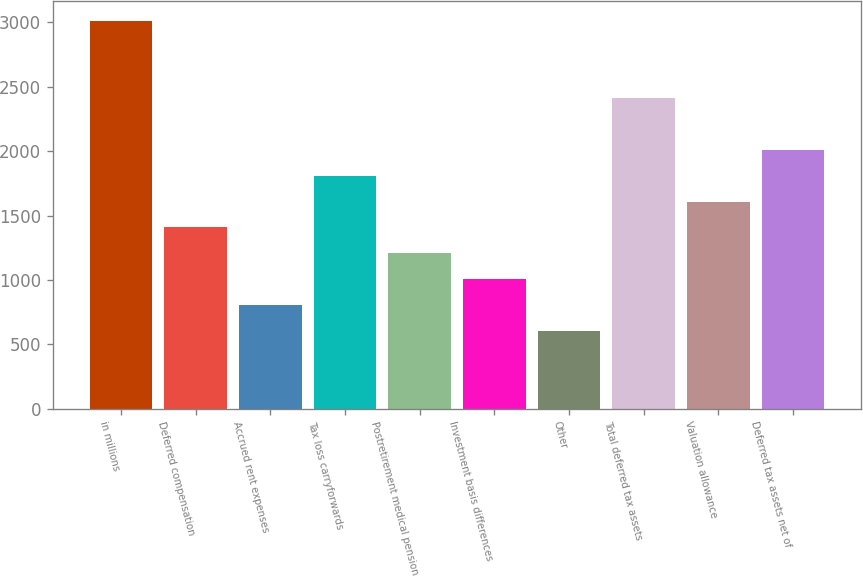Convert chart. <chart><loc_0><loc_0><loc_500><loc_500><bar_chart><fcel>in millions<fcel>Deferred compensation<fcel>Accrued rent expenses<fcel>Tax loss carryforwards<fcel>Postretirement medical pension<fcel>Investment basis differences<fcel>Other<fcel>Total deferred tax assets<fcel>Valuation allowance<fcel>Deferred tax assets net of<nl><fcel>3013.45<fcel>1407.93<fcel>805.86<fcel>1809.31<fcel>1207.24<fcel>1006.55<fcel>605.17<fcel>2411.38<fcel>1608.62<fcel>2010<nl></chart> 